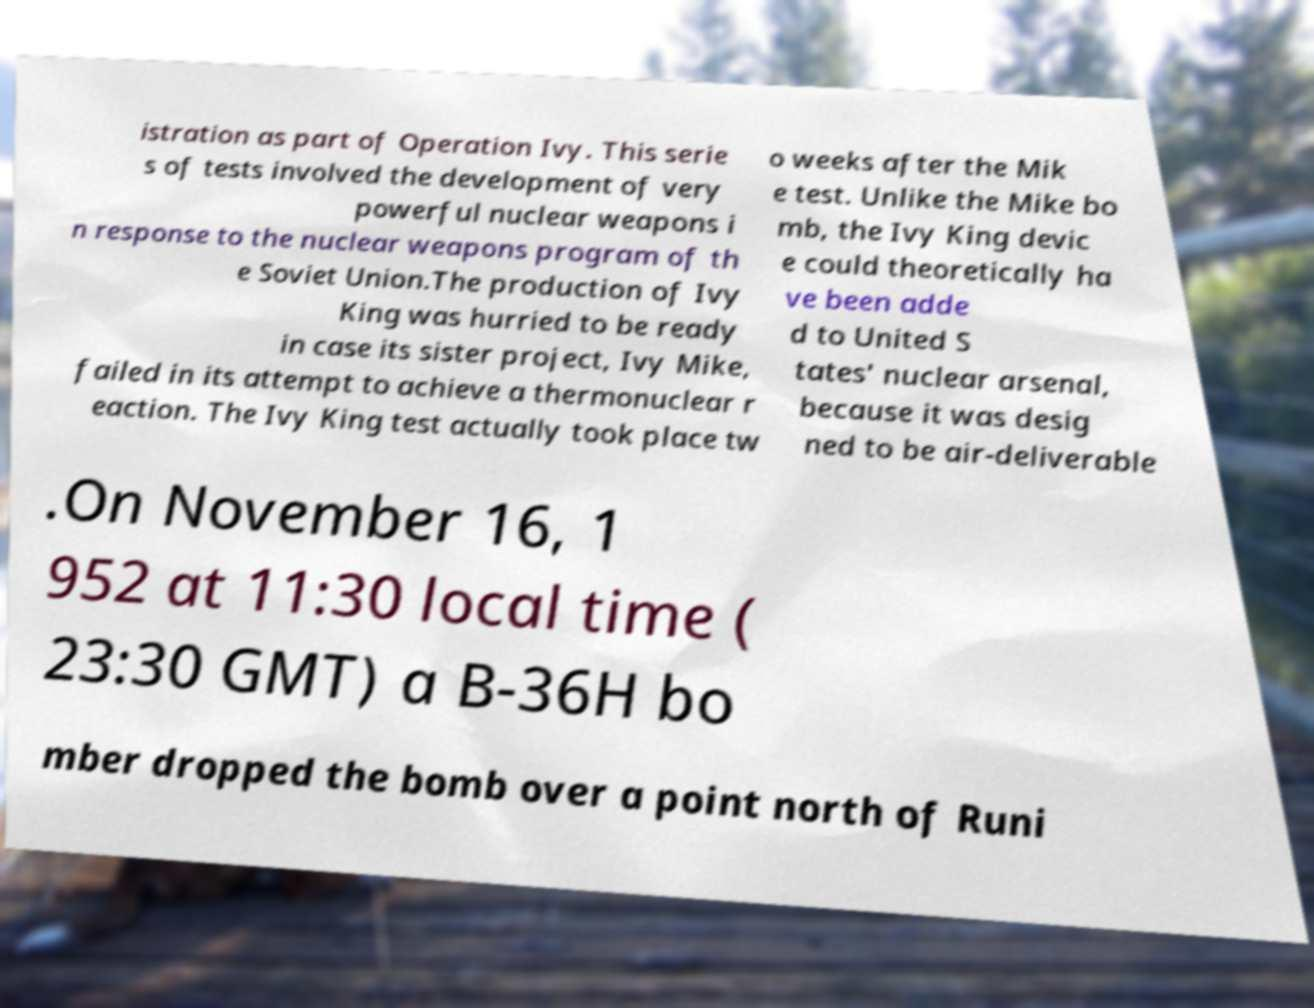Please read and relay the text visible in this image. What does it say? istration as part of Operation Ivy. This serie s of tests involved the development of very powerful nuclear weapons i n response to the nuclear weapons program of th e Soviet Union.The production of Ivy King was hurried to be ready in case its sister project, Ivy Mike, failed in its attempt to achieve a thermonuclear r eaction. The Ivy King test actually took place tw o weeks after the Mik e test. Unlike the Mike bo mb, the Ivy King devic e could theoretically ha ve been adde d to United S tates' nuclear arsenal, because it was desig ned to be air-deliverable .On November 16, 1 952 at 11:30 local time ( 23:30 GMT) a B-36H bo mber dropped the bomb over a point north of Runi 